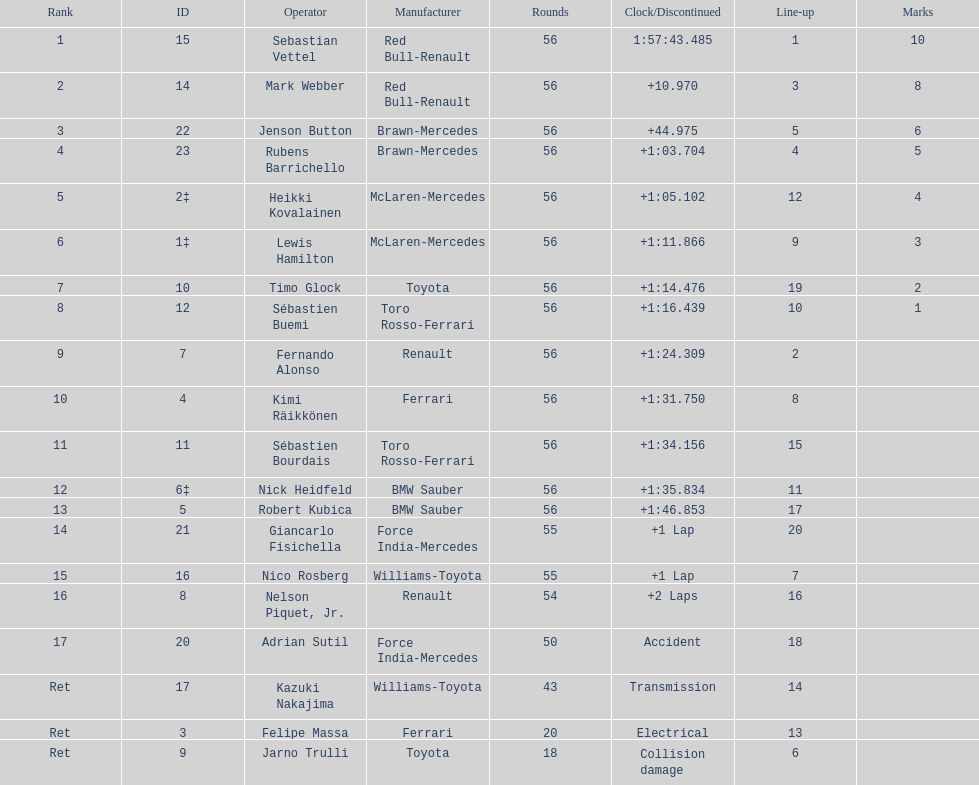Which driver is the only driver who retired because of collision damage? Jarno Trulli. 